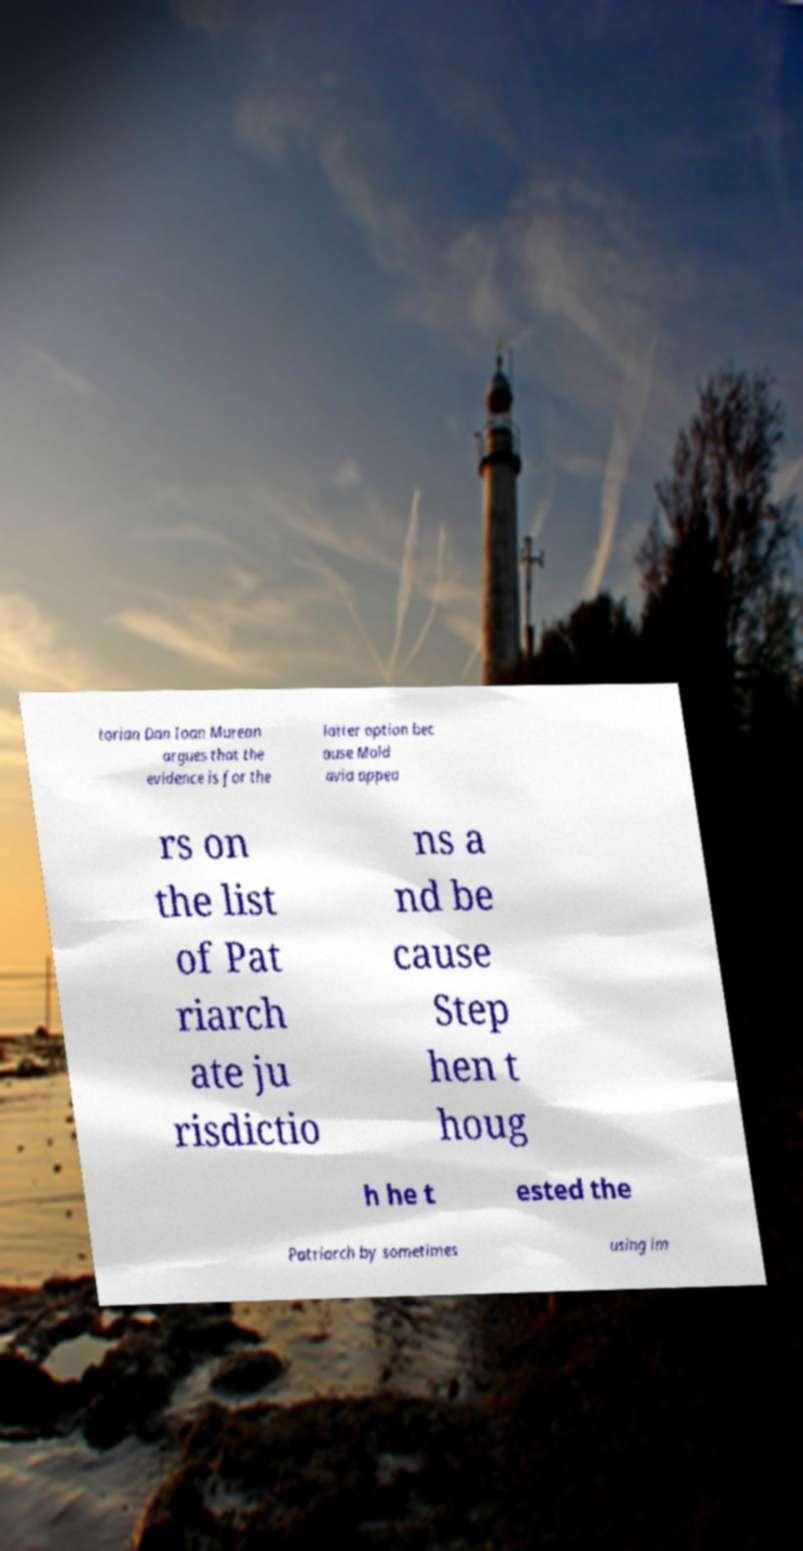For documentation purposes, I need the text within this image transcribed. Could you provide that? torian Dan Ioan Murean argues that the evidence is for the latter option bec ause Mold avia appea rs on the list of Pat riarch ate ju risdictio ns a nd be cause Step hen t houg h he t ested the Patriarch by sometimes using im 